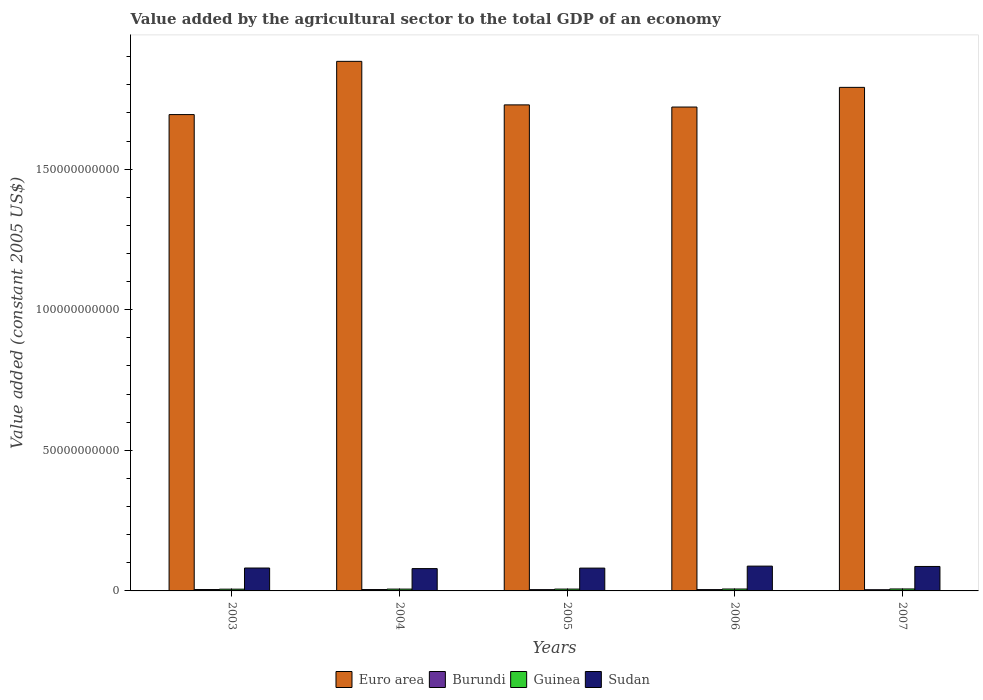How many different coloured bars are there?
Offer a very short reply. 4. Are the number of bars per tick equal to the number of legend labels?
Offer a very short reply. Yes. Are the number of bars on each tick of the X-axis equal?
Your response must be concise. Yes. How many bars are there on the 5th tick from the left?
Keep it short and to the point. 4. What is the label of the 1st group of bars from the left?
Ensure brevity in your answer.  2003. In how many cases, is the number of bars for a given year not equal to the number of legend labels?
Your response must be concise. 0. What is the value added by the agricultural sector in Euro area in 2007?
Your answer should be compact. 1.79e+11. Across all years, what is the maximum value added by the agricultural sector in Sudan?
Provide a short and direct response. 8.82e+09. Across all years, what is the minimum value added by the agricultural sector in Sudan?
Offer a terse response. 7.94e+09. What is the total value added by the agricultural sector in Burundi in the graph?
Offer a very short reply. 2.33e+09. What is the difference between the value added by the agricultural sector in Burundi in 2004 and that in 2007?
Provide a short and direct response. 5.92e+07. What is the difference between the value added by the agricultural sector in Sudan in 2005 and the value added by the agricultural sector in Burundi in 2004?
Make the answer very short. 7.63e+09. What is the average value added by the agricultural sector in Sudan per year?
Keep it short and to the point. 8.34e+09. In the year 2003, what is the difference between the value added by the agricultural sector in Guinea and value added by the agricultural sector in Sudan?
Keep it short and to the point. -7.52e+09. In how many years, is the value added by the agricultural sector in Burundi greater than 30000000000 US$?
Your answer should be very brief. 0. What is the ratio of the value added by the agricultural sector in Euro area in 2003 to that in 2006?
Keep it short and to the point. 0.98. Is the difference between the value added by the agricultural sector in Guinea in 2003 and 2005 greater than the difference between the value added by the agricultural sector in Sudan in 2003 and 2005?
Give a very brief answer. No. What is the difference between the highest and the second highest value added by the agricultural sector in Burundi?
Your answer should be compact. 1.17e+06. What is the difference between the highest and the lowest value added by the agricultural sector in Euro area?
Your answer should be very brief. 1.89e+1. Is the sum of the value added by the agricultural sector in Euro area in 2004 and 2007 greater than the maximum value added by the agricultural sector in Guinea across all years?
Your answer should be compact. Yes. What does the 3rd bar from the left in 2006 represents?
Keep it short and to the point. Guinea. What does the 1st bar from the right in 2006 represents?
Your answer should be compact. Sudan. How many years are there in the graph?
Your response must be concise. 5. What is the difference between two consecutive major ticks on the Y-axis?
Provide a succinct answer. 5.00e+1. Are the values on the major ticks of Y-axis written in scientific E-notation?
Your answer should be compact. No. Does the graph contain grids?
Give a very brief answer. No. Where does the legend appear in the graph?
Make the answer very short. Bottom center. How many legend labels are there?
Your response must be concise. 4. What is the title of the graph?
Your response must be concise. Value added by the agricultural sector to the total GDP of an economy. What is the label or title of the X-axis?
Offer a terse response. Years. What is the label or title of the Y-axis?
Provide a short and direct response. Value added (constant 2005 US$). What is the Value added (constant 2005 US$) of Euro area in 2003?
Offer a very short reply. 1.69e+11. What is the Value added (constant 2005 US$) in Burundi in 2003?
Make the answer very short. 4.90e+08. What is the Value added (constant 2005 US$) of Guinea in 2003?
Keep it short and to the point. 6.26e+08. What is the Value added (constant 2005 US$) in Sudan in 2003?
Ensure brevity in your answer.  8.14e+09. What is the Value added (constant 2005 US$) of Euro area in 2004?
Make the answer very short. 1.88e+11. What is the Value added (constant 2005 US$) of Burundi in 2004?
Your answer should be very brief. 4.88e+08. What is the Value added (constant 2005 US$) of Guinea in 2004?
Make the answer very short. 6.46e+08. What is the Value added (constant 2005 US$) of Sudan in 2004?
Offer a terse response. 7.94e+09. What is the Value added (constant 2005 US$) in Euro area in 2005?
Make the answer very short. 1.73e+11. What is the Value added (constant 2005 US$) of Burundi in 2005?
Offer a terse response. 4.56e+08. What is the Value added (constant 2005 US$) of Guinea in 2005?
Make the answer very short. 6.54e+08. What is the Value added (constant 2005 US$) of Sudan in 2005?
Give a very brief answer. 8.12e+09. What is the Value added (constant 2005 US$) of Euro area in 2006?
Your answer should be compact. 1.72e+11. What is the Value added (constant 2005 US$) of Burundi in 2006?
Keep it short and to the point. 4.71e+08. What is the Value added (constant 2005 US$) of Guinea in 2006?
Give a very brief answer. 6.80e+08. What is the Value added (constant 2005 US$) of Sudan in 2006?
Ensure brevity in your answer.  8.82e+09. What is the Value added (constant 2005 US$) in Euro area in 2007?
Keep it short and to the point. 1.79e+11. What is the Value added (constant 2005 US$) of Burundi in 2007?
Ensure brevity in your answer.  4.29e+08. What is the Value added (constant 2005 US$) of Guinea in 2007?
Ensure brevity in your answer.  6.99e+08. What is the Value added (constant 2005 US$) in Sudan in 2007?
Ensure brevity in your answer.  8.70e+09. Across all years, what is the maximum Value added (constant 2005 US$) of Euro area?
Offer a very short reply. 1.88e+11. Across all years, what is the maximum Value added (constant 2005 US$) in Burundi?
Your answer should be very brief. 4.90e+08. Across all years, what is the maximum Value added (constant 2005 US$) of Guinea?
Your answer should be very brief. 6.99e+08. Across all years, what is the maximum Value added (constant 2005 US$) of Sudan?
Your answer should be very brief. 8.82e+09. Across all years, what is the minimum Value added (constant 2005 US$) in Euro area?
Your answer should be compact. 1.69e+11. Across all years, what is the minimum Value added (constant 2005 US$) in Burundi?
Provide a short and direct response. 4.29e+08. Across all years, what is the minimum Value added (constant 2005 US$) in Guinea?
Provide a short and direct response. 6.26e+08. Across all years, what is the minimum Value added (constant 2005 US$) in Sudan?
Provide a short and direct response. 7.94e+09. What is the total Value added (constant 2005 US$) in Euro area in the graph?
Offer a very short reply. 8.82e+11. What is the total Value added (constant 2005 US$) of Burundi in the graph?
Provide a succinct answer. 2.33e+09. What is the total Value added (constant 2005 US$) of Guinea in the graph?
Provide a succinct answer. 3.30e+09. What is the total Value added (constant 2005 US$) of Sudan in the graph?
Keep it short and to the point. 4.17e+1. What is the difference between the Value added (constant 2005 US$) of Euro area in 2003 and that in 2004?
Your answer should be very brief. -1.89e+1. What is the difference between the Value added (constant 2005 US$) in Burundi in 2003 and that in 2004?
Offer a very short reply. 1.17e+06. What is the difference between the Value added (constant 2005 US$) of Guinea in 2003 and that in 2004?
Offer a terse response. -2.01e+07. What is the difference between the Value added (constant 2005 US$) in Sudan in 2003 and that in 2004?
Make the answer very short. 2.04e+08. What is the difference between the Value added (constant 2005 US$) of Euro area in 2003 and that in 2005?
Provide a short and direct response. -3.45e+09. What is the difference between the Value added (constant 2005 US$) of Burundi in 2003 and that in 2005?
Keep it short and to the point. 3.32e+07. What is the difference between the Value added (constant 2005 US$) of Guinea in 2003 and that in 2005?
Keep it short and to the point. -2.87e+07. What is the difference between the Value added (constant 2005 US$) in Sudan in 2003 and that in 2005?
Your response must be concise. 2.61e+07. What is the difference between the Value added (constant 2005 US$) of Euro area in 2003 and that in 2006?
Your answer should be very brief. -2.68e+09. What is the difference between the Value added (constant 2005 US$) in Burundi in 2003 and that in 2006?
Your answer should be compact. 1.88e+07. What is the difference between the Value added (constant 2005 US$) in Guinea in 2003 and that in 2006?
Offer a terse response. -5.43e+07. What is the difference between the Value added (constant 2005 US$) of Sudan in 2003 and that in 2006?
Provide a short and direct response. -6.79e+08. What is the difference between the Value added (constant 2005 US$) in Euro area in 2003 and that in 2007?
Keep it short and to the point. -9.68e+09. What is the difference between the Value added (constant 2005 US$) of Burundi in 2003 and that in 2007?
Give a very brief answer. 6.03e+07. What is the difference between the Value added (constant 2005 US$) in Guinea in 2003 and that in 2007?
Ensure brevity in your answer.  -7.33e+07. What is the difference between the Value added (constant 2005 US$) in Sudan in 2003 and that in 2007?
Your answer should be very brief. -5.57e+08. What is the difference between the Value added (constant 2005 US$) in Euro area in 2004 and that in 2005?
Make the answer very short. 1.55e+1. What is the difference between the Value added (constant 2005 US$) in Burundi in 2004 and that in 2005?
Your answer should be very brief. 3.20e+07. What is the difference between the Value added (constant 2005 US$) of Guinea in 2004 and that in 2005?
Your answer should be very brief. -8.65e+06. What is the difference between the Value added (constant 2005 US$) in Sudan in 2004 and that in 2005?
Offer a terse response. -1.78e+08. What is the difference between the Value added (constant 2005 US$) of Euro area in 2004 and that in 2006?
Make the answer very short. 1.62e+1. What is the difference between the Value added (constant 2005 US$) of Burundi in 2004 and that in 2006?
Offer a very short reply. 1.77e+07. What is the difference between the Value added (constant 2005 US$) of Guinea in 2004 and that in 2006?
Give a very brief answer. -3.42e+07. What is the difference between the Value added (constant 2005 US$) of Sudan in 2004 and that in 2006?
Your answer should be very brief. -8.82e+08. What is the difference between the Value added (constant 2005 US$) in Euro area in 2004 and that in 2007?
Offer a terse response. 9.25e+09. What is the difference between the Value added (constant 2005 US$) of Burundi in 2004 and that in 2007?
Provide a succinct answer. 5.92e+07. What is the difference between the Value added (constant 2005 US$) in Guinea in 2004 and that in 2007?
Your answer should be compact. -5.33e+07. What is the difference between the Value added (constant 2005 US$) of Sudan in 2004 and that in 2007?
Your response must be concise. -7.61e+08. What is the difference between the Value added (constant 2005 US$) of Euro area in 2005 and that in 2006?
Keep it short and to the point. 7.70e+08. What is the difference between the Value added (constant 2005 US$) of Burundi in 2005 and that in 2006?
Give a very brief answer. -1.44e+07. What is the difference between the Value added (constant 2005 US$) in Guinea in 2005 and that in 2006?
Your response must be concise. -2.56e+07. What is the difference between the Value added (constant 2005 US$) in Sudan in 2005 and that in 2006?
Provide a succinct answer. -7.05e+08. What is the difference between the Value added (constant 2005 US$) of Euro area in 2005 and that in 2007?
Provide a succinct answer. -6.23e+09. What is the difference between the Value added (constant 2005 US$) in Burundi in 2005 and that in 2007?
Your answer should be very brief. 2.71e+07. What is the difference between the Value added (constant 2005 US$) of Guinea in 2005 and that in 2007?
Provide a short and direct response. -4.46e+07. What is the difference between the Value added (constant 2005 US$) of Sudan in 2005 and that in 2007?
Ensure brevity in your answer.  -5.83e+08. What is the difference between the Value added (constant 2005 US$) in Euro area in 2006 and that in 2007?
Give a very brief answer. -7.00e+09. What is the difference between the Value added (constant 2005 US$) of Burundi in 2006 and that in 2007?
Your response must be concise. 4.15e+07. What is the difference between the Value added (constant 2005 US$) of Guinea in 2006 and that in 2007?
Give a very brief answer. -1.90e+07. What is the difference between the Value added (constant 2005 US$) of Sudan in 2006 and that in 2007?
Your answer should be very brief. 1.21e+08. What is the difference between the Value added (constant 2005 US$) in Euro area in 2003 and the Value added (constant 2005 US$) in Burundi in 2004?
Your response must be concise. 1.69e+11. What is the difference between the Value added (constant 2005 US$) of Euro area in 2003 and the Value added (constant 2005 US$) of Guinea in 2004?
Your response must be concise. 1.69e+11. What is the difference between the Value added (constant 2005 US$) in Euro area in 2003 and the Value added (constant 2005 US$) in Sudan in 2004?
Keep it short and to the point. 1.61e+11. What is the difference between the Value added (constant 2005 US$) in Burundi in 2003 and the Value added (constant 2005 US$) in Guinea in 2004?
Offer a terse response. -1.56e+08. What is the difference between the Value added (constant 2005 US$) in Burundi in 2003 and the Value added (constant 2005 US$) in Sudan in 2004?
Offer a terse response. -7.45e+09. What is the difference between the Value added (constant 2005 US$) in Guinea in 2003 and the Value added (constant 2005 US$) in Sudan in 2004?
Make the answer very short. -7.31e+09. What is the difference between the Value added (constant 2005 US$) of Euro area in 2003 and the Value added (constant 2005 US$) of Burundi in 2005?
Your answer should be very brief. 1.69e+11. What is the difference between the Value added (constant 2005 US$) of Euro area in 2003 and the Value added (constant 2005 US$) of Guinea in 2005?
Make the answer very short. 1.69e+11. What is the difference between the Value added (constant 2005 US$) in Euro area in 2003 and the Value added (constant 2005 US$) in Sudan in 2005?
Make the answer very short. 1.61e+11. What is the difference between the Value added (constant 2005 US$) in Burundi in 2003 and the Value added (constant 2005 US$) in Guinea in 2005?
Your response must be concise. -1.65e+08. What is the difference between the Value added (constant 2005 US$) of Burundi in 2003 and the Value added (constant 2005 US$) of Sudan in 2005?
Your answer should be compact. -7.63e+09. What is the difference between the Value added (constant 2005 US$) of Guinea in 2003 and the Value added (constant 2005 US$) of Sudan in 2005?
Give a very brief answer. -7.49e+09. What is the difference between the Value added (constant 2005 US$) of Euro area in 2003 and the Value added (constant 2005 US$) of Burundi in 2006?
Provide a succinct answer. 1.69e+11. What is the difference between the Value added (constant 2005 US$) of Euro area in 2003 and the Value added (constant 2005 US$) of Guinea in 2006?
Give a very brief answer. 1.69e+11. What is the difference between the Value added (constant 2005 US$) in Euro area in 2003 and the Value added (constant 2005 US$) in Sudan in 2006?
Offer a terse response. 1.61e+11. What is the difference between the Value added (constant 2005 US$) of Burundi in 2003 and the Value added (constant 2005 US$) of Guinea in 2006?
Your answer should be compact. -1.90e+08. What is the difference between the Value added (constant 2005 US$) in Burundi in 2003 and the Value added (constant 2005 US$) in Sudan in 2006?
Your answer should be compact. -8.33e+09. What is the difference between the Value added (constant 2005 US$) in Guinea in 2003 and the Value added (constant 2005 US$) in Sudan in 2006?
Offer a very short reply. -8.20e+09. What is the difference between the Value added (constant 2005 US$) of Euro area in 2003 and the Value added (constant 2005 US$) of Burundi in 2007?
Your answer should be compact. 1.69e+11. What is the difference between the Value added (constant 2005 US$) of Euro area in 2003 and the Value added (constant 2005 US$) of Guinea in 2007?
Provide a succinct answer. 1.69e+11. What is the difference between the Value added (constant 2005 US$) of Euro area in 2003 and the Value added (constant 2005 US$) of Sudan in 2007?
Your answer should be very brief. 1.61e+11. What is the difference between the Value added (constant 2005 US$) in Burundi in 2003 and the Value added (constant 2005 US$) in Guinea in 2007?
Offer a terse response. -2.09e+08. What is the difference between the Value added (constant 2005 US$) in Burundi in 2003 and the Value added (constant 2005 US$) in Sudan in 2007?
Your answer should be compact. -8.21e+09. What is the difference between the Value added (constant 2005 US$) of Guinea in 2003 and the Value added (constant 2005 US$) of Sudan in 2007?
Provide a succinct answer. -8.07e+09. What is the difference between the Value added (constant 2005 US$) of Euro area in 2004 and the Value added (constant 2005 US$) of Burundi in 2005?
Your response must be concise. 1.88e+11. What is the difference between the Value added (constant 2005 US$) of Euro area in 2004 and the Value added (constant 2005 US$) of Guinea in 2005?
Provide a succinct answer. 1.88e+11. What is the difference between the Value added (constant 2005 US$) in Euro area in 2004 and the Value added (constant 2005 US$) in Sudan in 2005?
Your answer should be compact. 1.80e+11. What is the difference between the Value added (constant 2005 US$) in Burundi in 2004 and the Value added (constant 2005 US$) in Guinea in 2005?
Ensure brevity in your answer.  -1.66e+08. What is the difference between the Value added (constant 2005 US$) of Burundi in 2004 and the Value added (constant 2005 US$) of Sudan in 2005?
Offer a very short reply. -7.63e+09. What is the difference between the Value added (constant 2005 US$) in Guinea in 2004 and the Value added (constant 2005 US$) in Sudan in 2005?
Offer a very short reply. -7.47e+09. What is the difference between the Value added (constant 2005 US$) in Euro area in 2004 and the Value added (constant 2005 US$) in Burundi in 2006?
Keep it short and to the point. 1.88e+11. What is the difference between the Value added (constant 2005 US$) in Euro area in 2004 and the Value added (constant 2005 US$) in Guinea in 2006?
Offer a terse response. 1.88e+11. What is the difference between the Value added (constant 2005 US$) of Euro area in 2004 and the Value added (constant 2005 US$) of Sudan in 2006?
Your answer should be very brief. 1.80e+11. What is the difference between the Value added (constant 2005 US$) of Burundi in 2004 and the Value added (constant 2005 US$) of Guinea in 2006?
Your answer should be very brief. -1.92e+08. What is the difference between the Value added (constant 2005 US$) in Burundi in 2004 and the Value added (constant 2005 US$) in Sudan in 2006?
Provide a short and direct response. -8.33e+09. What is the difference between the Value added (constant 2005 US$) of Guinea in 2004 and the Value added (constant 2005 US$) of Sudan in 2006?
Give a very brief answer. -8.18e+09. What is the difference between the Value added (constant 2005 US$) of Euro area in 2004 and the Value added (constant 2005 US$) of Burundi in 2007?
Provide a short and direct response. 1.88e+11. What is the difference between the Value added (constant 2005 US$) in Euro area in 2004 and the Value added (constant 2005 US$) in Guinea in 2007?
Keep it short and to the point. 1.88e+11. What is the difference between the Value added (constant 2005 US$) of Euro area in 2004 and the Value added (constant 2005 US$) of Sudan in 2007?
Your answer should be compact. 1.80e+11. What is the difference between the Value added (constant 2005 US$) of Burundi in 2004 and the Value added (constant 2005 US$) of Guinea in 2007?
Your response must be concise. -2.11e+08. What is the difference between the Value added (constant 2005 US$) in Burundi in 2004 and the Value added (constant 2005 US$) in Sudan in 2007?
Your answer should be compact. -8.21e+09. What is the difference between the Value added (constant 2005 US$) of Guinea in 2004 and the Value added (constant 2005 US$) of Sudan in 2007?
Provide a short and direct response. -8.05e+09. What is the difference between the Value added (constant 2005 US$) in Euro area in 2005 and the Value added (constant 2005 US$) in Burundi in 2006?
Provide a short and direct response. 1.72e+11. What is the difference between the Value added (constant 2005 US$) in Euro area in 2005 and the Value added (constant 2005 US$) in Guinea in 2006?
Ensure brevity in your answer.  1.72e+11. What is the difference between the Value added (constant 2005 US$) in Euro area in 2005 and the Value added (constant 2005 US$) in Sudan in 2006?
Make the answer very short. 1.64e+11. What is the difference between the Value added (constant 2005 US$) in Burundi in 2005 and the Value added (constant 2005 US$) in Guinea in 2006?
Offer a terse response. -2.24e+08. What is the difference between the Value added (constant 2005 US$) in Burundi in 2005 and the Value added (constant 2005 US$) in Sudan in 2006?
Provide a succinct answer. -8.36e+09. What is the difference between the Value added (constant 2005 US$) in Guinea in 2005 and the Value added (constant 2005 US$) in Sudan in 2006?
Your answer should be very brief. -8.17e+09. What is the difference between the Value added (constant 2005 US$) of Euro area in 2005 and the Value added (constant 2005 US$) of Burundi in 2007?
Provide a short and direct response. 1.72e+11. What is the difference between the Value added (constant 2005 US$) of Euro area in 2005 and the Value added (constant 2005 US$) of Guinea in 2007?
Your answer should be very brief. 1.72e+11. What is the difference between the Value added (constant 2005 US$) in Euro area in 2005 and the Value added (constant 2005 US$) in Sudan in 2007?
Keep it short and to the point. 1.64e+11. What is the difference between the Value added (constant 2005 US$) of Burundi in 2005 and the Value added (constant 2005 US$) of Guinea in 2007?
Your answer should be very brief. -2.43e+08. What is the difference between the Value added (constant 2005 US$) in Burundi in 2005 and the Value added (constant 2005 US$) in Sudan in 2007?
Give a very brief answer. -8.24e+09. What is the difference between the Value added (constant 2005 US$) of Guinea in 2005 and the Value added (constant 2005 US$) of Sudan in 2007?
Your answer should be compact. -8.05e+09. What is the difference between the Value added (constant 2005 US$) of Euro area in 2006 and the Value added (constant 2005 US$) of Burundi in 2007?
Keep it short and to the point. 1.72e+11. What is the difference between the Value added (constant 2005 US$) in Euro area in 2006 and the Value added (constant 2005 US$) in Guinea in 2007?
Offer a terse response. 1.71e+11. What is the difference between the Value added (constant 2005 US$) of Euro area in 2006 and the Value added (constant 2005 US$) of Sudan in 2007?
Your answer should be very brief. 1.63e+11. What is the difference between the Value added (constant 2005 US$) in Burundi in 2006 and the Value added (constant 2005 US$) in Guinea in 2007?
Offer a very short reply. -2.28e+08. What is the difference between the Value added (constant 2005 US$) in Burundi in 2006 and the Value added (constant 2005 US$) in Sudan in 2007?
Your response must be concise. -8.23e+09. What is the difference between the Value added (constant 2005 US$) in Guinea in 2006 and the Value added (constant 2005 US$) in Sudan in 2007?
Your response must be concise. -8.02e+09. What is the average Value added (constant 2005 US$) of Euro area per year?
Give a very brief answer. 1.76e+11. What is the average Value added (constant 2005 US$) of Burundi per year?
Make the answer very short. 4.67e+08. What is the average Value added (constant 2005 US$) of Guinea per year?
Provide a succinct answer. 6.61e+08. What is the average Value added (constant 2005 US$) in Sudan per year?
Ensure brevity in your answer.  8.34e+09. In the year 2003, what is the difference between the Value added (constant 2005 US$) of Euro area and Value added (constant 2005 US$) of Burundi?
Keep it short and to the point. 1.69e+11. In the year 2003, what is the difference between the Value added (constant 2005 US$) of Euro area and Value added (constant 2005 US$) of Guinea?
Make the answer very short. 1.69e+11. In the year 2003, what is the difference between the Value added (constant 2005 US$) in Euro area and Value added (constant 2005 US$) in Sudan?
Offer a very short reply. 1.61e+11. In the year 2003, what is the difference between the Value added (constant 2005 US$) of Burundi and Value added (constant 2005 US$) of Guinea?
Your answer should be compact. -1.36e+08. In the year 2003, what is the difference between the Value added (constant 2005 US$) in Burundi and Value added (constant 2005 US$) in Sudan?
Your answer should be compact. -7.65e+09. In the year 2003, what is the difference between the Value added (constant 2005 US$) in Guinea and Value added (constant 2005 US$) in Sudan?
Ensure brevity in your answer.  -7.52e+09. In the year 2004, what is the difference between the Value added (constant 2005 US$) in Euro area and Value added (constant 2005 US$) in Burundi?
Your answer should be compact. 1.88e+11. In the year 2004, what is the difference between the Value added (constant 2005 US$) of Euro area and Value added (constant 2005 US$) of Guinea?
Provide a short and direct response. 1.88e+11. In the year 2004, what is the difference between the Value added (constant 2005 US$) of Euro area and Value added (constant 2005 US$) of Sudan?
Offer a terse response. 1.80e+11. In the year 2004, what is the difference between the Value added (constant 2005 US$) of Burundi and Value added (constant 2005 US$) of Guinea?
Offer a terse response. -1.57e+08. In the year 2004, what is the difference between the Value added (constant 2005 US$) of Burundi and Value added (constant 2005 US$) of Sudan?
Provide a succinct answer. -7.45e+09. In the year 2004, what is the difference between the Value added (constant 2005 US$) in Guinea and Value added (constant 2005 US$) in Sudan?
Provide a short and direct response. -7.29e+09. In the year 2005, what is the difference between the Value added (constant 2005 US$) in Euro area and Value added (constant 2005 US$) in Burundi?
Make the answer very short. 1.72e+11. In the year 2005, what is the difference between the Value added (constant 2005 US$) in Euro area and Value added (constant 2005 US$) in Guinea?
Offer a very short reply. 1.72e+11. In the year 2005, what is the difference between the Value added (constant 2005 US$) in Euro area and Value added (constant 2005 US$) in Sudan?
Offer a terse response. 1.65e+11. In the year 2005, what is the difference between the Value added (constant 2005 US$) of Burundi and Value added (constant 2005 US$) of Guinea?
Keep it short and to the point. -1.98e+08. In the year 2005, what is the difference between the Value added (constant 2005 US$) of Burundi and Value added (constant 2005 US$) of Sudan?
Your answer should be compact. -7.66e+09. In the year 2005, what is the difference between the Value added (constant 2005 US$) of Guinea and Value added (constant 2005 US$) of Sudan?
Provide a short and direct response. -7.46e+09. In the year 2006, what is the difference between the Value added (constant 2005 US$) of Euro area and Value added (constant 2005 US$) of Burundi?
Ensure brevity in your answer.  1.72e+11. In the year 2006, what is the difference between the Value added (constant 2005 US$) in Euro area and Value added (constant 2005 US$) in Guinea?
Keep it short and to the point. 1.71e+11. In the year 2006, what is the difference between the Value added (constant 2005 US$) of Euro area and Value added (constant 2005 US$) of Sudan?
Your answer should be very brief. 1.63e+11. In the year 2006, what is the difference between the Value added (constant 2005 US$) in Burundi and Value added (constant 2005 US$) in Guinea?
Provide a short and direct response. -2.09e+08. In the year 2006, what is the difference between the Value added (constant 2005 US$) in Burundi and Value added (constant 2005 US$) in Sudan?
Provide a succinct answer. -8.35e+09. In the year 2006, what is the difference between the Value added (constant 2005 US$) of Guinea and Value added (constant 2005 US$) of Sudan?
Keep it short and to the point. -8.14e+09. In the year 2007, what is the difference between the Value added (constant 2005 US$) of Euro area and Value added (constant 2005 US$) of Burundi?
Your answer should be compact. 1.79e+11. In the year 2007, what is the difference between the Value added (constant 2005 US$) in Euro area and Value added (constant 2005 US$) in Guinea?
Offer a terse response. 1.78e+11. In the year 2007, what is the difference between the Value added (constant 2005 US$) of Euro area and Value added (constant 2005 US$) of Sudan?
Ensure brevity in your answer.  1.70e+11. In the year 2007, what is the difference between the Value added (constant 2005 US$) of Burundi and Value added (constant 2005 US$) of Guinea?
Provide a short and direct response. -2.70e+08. In the year 2007, what is the difference between the Value added (constant 2005 US$) of Burundi and Value added (constant 2005 US$) of Sudan?
Give a very brief answer. -8.27e+09. In the year 2007, what is the difference between the Value added (constant 2005 US$) of Guinea and Value added (constant 2005 US$) of Sudan?
Offer a very short reply. -8.00e+09. What is the ratio of the Value added (constant 2005 US$) in Euro area in 2003 to that in 2004?
Provide a succinct answer. 0.9. What is the ratio of the Value added (constant 2005 US$) in Guinea in 2003 to that in 2004?
Your answer should be very brief. 0.97. What is the ratio of the Value added (constant 2005 US$) in Sudan in 2003 to that in 2004?
Offer a terse response. 1.03. What is the ratio of the Value added (constant 2005 US$) of Burundi in 2003 to that in 2005?
Make the answer very short. 1.07. What is the ratio of the Value added (constant 2005 US$) in Guinea in 2003 to that in 2005?
Provide a succinct answer. 0.96. What is the ratio of the Value added (constant 2005 US$) of Euro area in 2003 to that in 2006?
Ensure brevity in your answer.  0.98. What is the ratio of the Value added (constant 2005 US$) in Burundi in 2003 to that in 2006?
Offer a terse response. 1.04. What is the ratio of the Value added (constant 2005 US$) of Guinea in 2003 to that in 2006?
Give a very brief answer. 0.92. What is the ratio of the Value added (constant 2005 US$) in Sudan in 2003 to that in 2006?
Your response must be concise. 0.92. What is the ratio of the Value added (constant 2005 US$) of Euro area in 2003 to that in 2007?
Provide a short and direct response. 0.95. What is the ratio of the Value added (constant 2005 US$) in Burundi in 2003 to that in 2007?
Give a very brief answer. 1.14. What is the ratio of the Value added (constant 2005 US$) in Guinea in 2003 to that in 2007?
Your response must be concise. 0.9. What is the ratio of the Value added (constant 2005 US$) in Sudan in 2003 to that in 2007?
Your response must be concise. 0.94. What is the ratio of the Value added (constant 2005 US$) in Euro area in 2004 to that in 2005?
Your answer should be compact. 1.09. What is the ratio of the Value added (constant 2005 US$) in Burundi in 2004 to that in 2005?
Give a very brief answer. 1.07. What is the ratio of the Value added (constant 2005 US$) in Sudan in 2004 to that in 2005?
Your response must be concise. 0.98. What is the ratio of the Value added (constant 2005 US$) in Euro area in 2004 to that in 2006?
Your answer should be compact. 1.09. What is the ratio of the Value added (constant 2005 US$) of Burundi in 2004 to that in 2006?
Ensure brevity in your answer.  1.04. What is the ratio of the Value added (constant 2005 US$) of Guinea in 2004 to that in 2006?
Make the answer very short. 0.95. What is the ratio of the Value added (constant 2005 US$) of Sudan in 2004 to that in 2006?
Offer a terse response. 0.9. What is the ratio of the Value added (constant 2005 US$) of Euro area in 2004 to that in 2007?
Make the answer very short. 1.05. What is the ratio of the Value added (constant 2005 US$) of Burundi in 2004 to that in 2007?
Offer a terse response. 1.14. What is the ratio of the Value added (constant 2005 US$) of Guinea in 2004 to that in 2007?
Provide a short and direct response. 0.92. What is the ratio of the Value added (constant 2005 US$) in Sudan in 2004 to that in 2007?
Provide a short and direct response. 0.91. What is the ratio of the Value added (constant 2005 US$) of Burundi in 2005 to that in 2006?
Make the answer very short. 0.97. What is the ratio of the Value added (constant 2005 US$) of Guinea in 2005 to that in 2006?
Your answer should be very brief. 0.96. What is the ratio of the Value added (constant 2005 US$) of Sudan in 2005 to that in 2006?
Give a very brief answer. 0.92. What is the ratio of the Value added (constant 2005 US$) of Euro area in 2005 to that in 2007?
Your answer should be very brief. 0.97. What is the ratio of the Value added (constant 2005 US$) in Burundi in 2005 to that in 2007?
Offer a terse response. 1.06. What is the ratio of the Value added (constant 2005 US$) in Guinea in 2005 to that in 2007?
Offer a terse response. 0.94. What is the ratio of the Value added (constant 2005 US$) in Sudan in 2005 to that in 2007?
Offer a very short reply. 0.93. What is the ratio of the Value added (constant 2005 US$) in Euro area in 2006 to that in 2007?
Provide a short and direct response. 0.96. What is the ratio of the Value added (constant 2005 US$) of Burundi in 2006 to that in 2007?
Give a very brief answer. 1.1. What is the ratio of the Value added (constant 2005 US$) in Guinea in 2006 to that in 2007?
Your response must be concise. 0.97. What is the difference between the highest and the second highest Value added (constant 2005 US$) of Euro area?
Provide a short and direct response. 9.25e+09. What is the difference between the highest and the second highest Value added (constant 2005 US$) in Burundi?
Offer a terse response. 1.17e+06. What is the difference between the highest and the second highest Value added (constant 2005 US$) in Guinea?
Give a very brief answer. 1.90e+07. What is the difference between the highest and the second highest Value added (constant 2005 US$) in Sudan?
Provide a succinct answer. 1.21e+08. What is the difference between the highest and the lowest Value added (constant 2005 US$) of Euro area?
Offer a very short reply. 1.89e+1. What is the difference between the highest and the lowest Value added (constant 2005 US$) of Burundi?
Make the answer very short. 6.03e+07. What is the difference between the highest and the lowest Value added (constant 2005 US$) of Guinea?
Ensure brevity in your answer.  7.33e+07. What is the difference between the highest and the lowest Value added (constant 2005 US$) of Sudan?
Provide a succinct answer. 8.82e+08. 